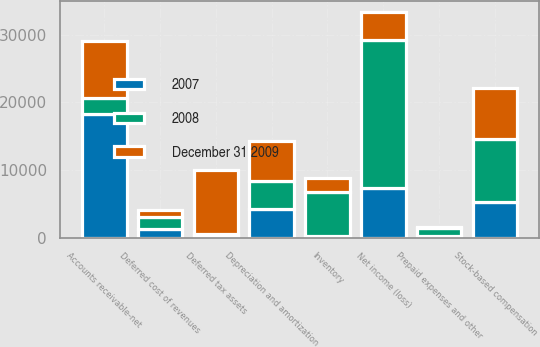Convert chart to OTSL. <chart><loc_0><loc_0><loc_500><loc_500><stacked_bar_chart><ecel><fcel>Net income (loss)<fcel>Depreciation and amortization<fcel>Stock-based compensation<fcel>Accounts receivable-net<fcel>Inventory<fcel>Deferred tax assets<fcel>Prepaid expenses and other<fcel>Deferred cost of revenues<nl><fcel>December 31 2009<fcel>4153<fcel>5935<fcel>7461<fcel>8508<fcel>2012<fcel>9578<fcel>190<fcel>1063<nl><fcel>2007<fcel>7363<fcel>4234<fcel>5299<fcel>18350<fcel>189<fcel>205<fcel>214<fcel>1231<nl><fcel>2008<fcel>21842<fcel>4153<fcel>9332<fcel>2268<fcel>6597<fcel>286<fcel>1226<fcel>1800<nl></chart> 